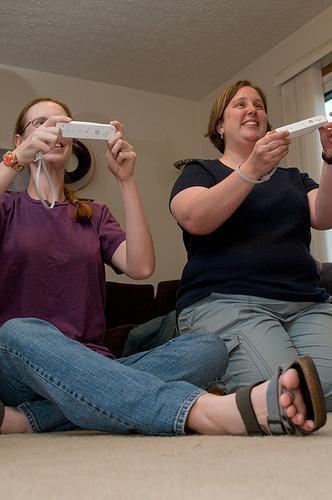What are these women looking at?
Select the accurate response from the four choices given to answer the question.
Options: Mirror, car, monitor screen, rainbow. Monitor screen. 